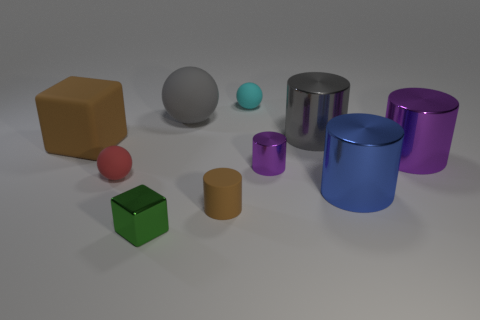How many other objects are the same color as the shiny cube?
Offer a very short reply. 0. Is the size of the red matte thing the same as the green metal block?
Ensure brevity in your answer.  Yes. How many objects are either small green cubes or small matte objects that are to the left of the tiny green block?
Make the answer very short. 2. Is the number of tiny red things that are right of the cyan object less than the number of rubber cylinders that are to the left of the large gray ball?
Offer a terse response. No. How many other things are made of the same material as the large blue cylinder?
Your answer should be compact. 4. Does the large rubber object that is in front of the gray metal cylinder have the same color as the rubber cylinder?
Keep it short and to the point. Yes. There is a big cylinder that is on the right side of the blue cylinder; are there any purple cylinders to the right of it?
Offer a terse response. No. What material is the large thing that is in front of the big gray metal thing and on the left side of the tiny purple thing?
Your answer should be very brief. Rubber. What is the shape of the small green thing that is made of the same material as the gray cylinder?
Make the answer very short. Cube. Do the gray thing that is to the right of the tiny purple metal thing and the small brown thing have the same material?
Ensure brevity in your answer.  No. 